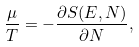<formula> <loc_0><loc_0><loc_500><loc_500>\frac { \mu } { T } = - \frac { \partial S ( E , N ) } { \partial N } ,</formula> 